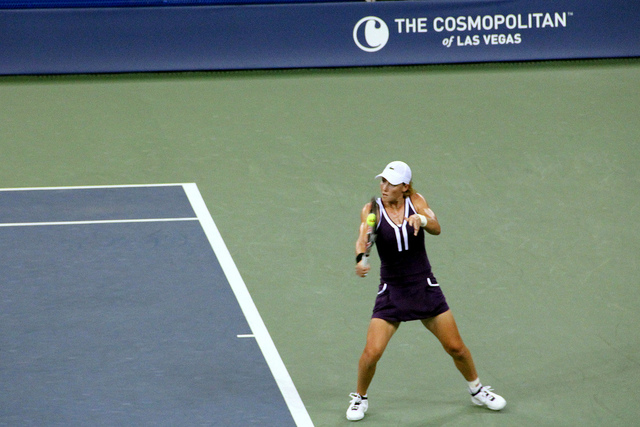Please extract the text content from this image. THE COSMOPOLITAN LAS VEGAS of 